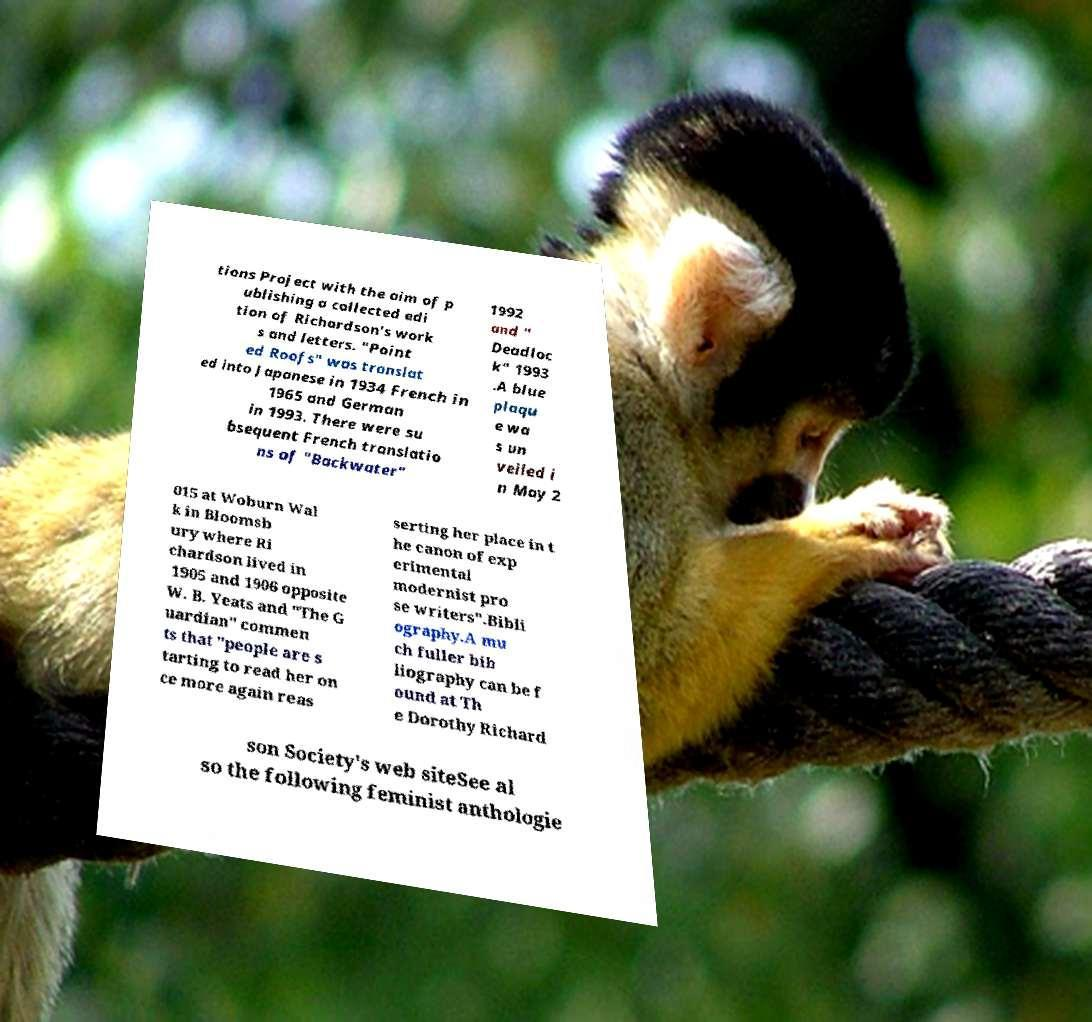Can you accurately transcribe the text from the provided image for me? tions Project with the aim of p ublishing a collected edi tion of Richardson's work s and letters. "Point ed Roofs" was translat ed into Japanese in 1934 French in 1965 and German in 1993. There were su bsequent French translatio ns of "Backwater" 1992 and " Deadloc k" 1993 .A blue plaqu e wa s un veiled i n May 2 015 at Woburn Wal k in Bloomsb ury where Ri chardson lived in 1905 and 1906 opposite W. B. Yeats and "The G uardian" commen ts that "people are s tarting to read her on ce more again reas serting her place in t he canon of exp erimental modernist pro se writers".Bibli ography.A mu ch fuller bib liography can be f ound at Th e Dorothy Richard son Society's web siteSee al so the following feminist anthologie 